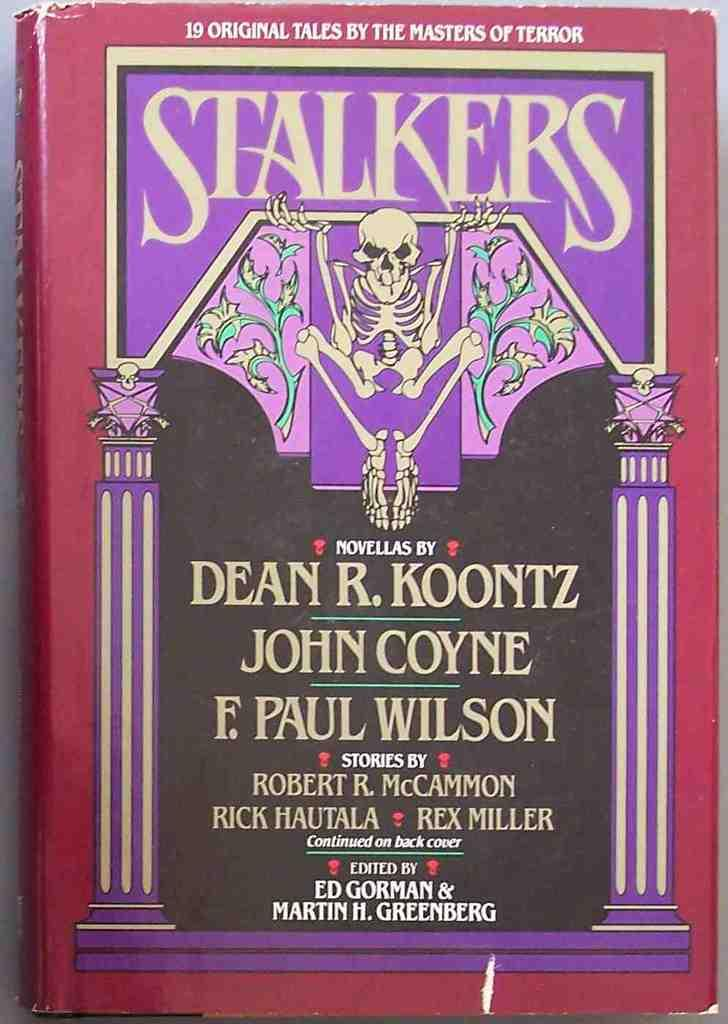<image>
Create a compact narrative representing the image presented. A book called Stalkers shows a skeleton on the front 